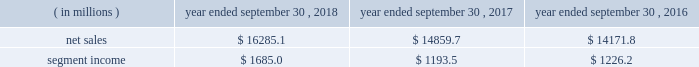Holders of grupo gondi manage the joint venture and we provide technical and commercial resources .
We believe the joint venture is helping us to grow our presence in the attractive mexican market .
We have included the financial results of the joint venture in our corrugated packaging segment since the date of formation .
We are accounting for the investment on the equity method .
On january 19 , 2016 , we completed the packaging acquisition .
The entities acquired provide value-added folding carton and litho-laminated display packaging solutions .
We believe the transaction has provided us with attractive and complementary customers , markets and facilities .
We have included the financial results of the acquired entities in our consumer packaging segment since the date of the acquisition .
On october 1 , 2015 , we completed the sp fiber acquisition .
The transaction included the acquisition of mills located in dublin , ga and newberg , or , which produce lightweight recycled containerboard and kraft and bag paper .
The newberg mill also produced newsprint .
As part of the transaction , we also acquired sp fiber's 48% ( 48 % ) interest in green power solutions of georgia , llc ( fffdgps fffd ) , which we consolidate .
Gps is a joint venture providing steam to the dublin mill and electricity to georgia power .
Subsequent to the transaction , we announced the permanent closure of the newberg mill due to the decline in market conditions of the newsprint business and our need to balance supply and demand in our containerboard system .
We have included the financial results of the acquired entities in our corrugated packaging segment since the date of the acquisition .
See fffdnote 2 .
Mergers , acquisitions and investment fffdtt of the notes to consolidated financial statements for additional information .
See also item 1a .
Fffdrisk factors fffd fffdwe may be unsuccessful in making and integrating mergers , acquisitions and investments and completing divestitures fffd .
Business .
In fiscal 2018 , we continued to pursue our strategy of offering differentiated paper and packaging solutions that help our customers win .
We successfully executed this strategy in fiscal 2018 in a rapidly changing cost and price environment .
Net sales of $ 16285.1 million for fiscal 2018 increased $ 1425.4 million , or 9.6% ( 9.6 % ) , compared to fiscal 2017 .
The increase was primarily a result of an increase in corrugated packaging segment sales , driven by higher selling price/mix and the contributions from acquisitions , and increased consumer packaging segment sales , primarily due to the contribution from acquisitions ( primarily the mps acquisition ) .
These increases were partially offset by the absence of net sales from hh&b in fiscal 2018 due to the sale of hh&b in april 2017 and lower land and development segment sales compared to the prior year period due to the timing of real estate sales as we monetize the portfolio and lower merchandising display sales in the consumer packaging segment .
Segment income increased $ 491.5 million in fiscal 2018 compared to fiscal 2017 , primarily due to increased corrugated packaging segment income .
With respect to segment income , we experienced higher levels of cost inflation during fiscal 2018 as compared to fiscal 2017 , which was partially offset by recycled fiber deflation .
The primary inflationary items were freight costs , chemical costs , virgin fiber costs and wage and other costs .
Productivity improvements in fiscal 2018 more than offset the net impact of cost inflation .
While it is difficult to predict specific inflationary items , we expect higher cost inflation to continue through fiscal 2019 .
Our corrugated packaging segment increased its net sales by $ 695.1 million in fiscal 2018 to $ 9103.4 million from $ 8408.3 million in fiscal 2017 .
The increase in net sales was primarily due to higher corrugated selling price/mix and higher corrugated volumes ( including acquisitions ) , which were partially offset by lower net sales from recycling operations due to lower recycled fiber costs , lower sales related to the deconsolidation of a foreign joint venture in fiscal 2017 and the impact of foreign currency .
North american box shipments increased 4.1% ( 4.1 % ) on a per day basis in fiscal 2018 compared to fiscal 2017 .
Segment income attributable to the corrugated packaging segment in fiscal 2018 increased $ 454.0 million to $ 1207.9 million compared to $ 753.9 million in fiscal 2017 .
The increase was primarily due to higher selling price/mix , lower recycled fiber costs and productivity improvements which were partially offset by higher levels of cost inflation and other items , including increased depreciation and amortization .
Our consumer packaging segment increased its net sales by $ 838.9 million in fiscal 2018 to $ 7291.4 million from $ 6452.5 million in fiscal 2017 .
The increase in net sales was primarily due to an increase in net sales from acquisitions ( primarily the mps acquisition ) and higher selling price/mix partially offset by the absence of net sales from hh&b in fiscal 2018 due to the hh&b sale in april 2017 and lower volumes .
Segment income attributable to .
What percentage of net sales was the consumer packaging segment in 2018? 
Rationale: in line 36 , it gives us the amount of of net sales produced by the consumer packaging segment . to find the answer you take net sales subtract that by the number given in line 36 . then divide the solution by net sales .
Computations: ((16285.1 - 7291.4) / 16285.1)
Answer: 0.55227. Holders of grupo gondi manage the joint venture and we provide technical and commercial resources .
We believe the joint venture is helping us to grow our presence in the attractive mexican market .
We have included the financial results of the joint venture in our corrugated packaging segment since the date of formation .
We are accounting for the investment on the equity method .
On january 19 , 2016 , we completed the packaging acquisition .
The entities acquired provide value-added folding carton and litho-laminated display packaging solutions .
We believe the transaction has provided us with attractive and complementary customers , markets and facilities .
We have included the financial results of the acquired entities in our consumer packaging segment since the date of the acquisition .
On october 1 , 2015 , we completed the sp fiber acquisition .
The transaction included the acquisition of mills located in dublin , ga and newberg , or , which produce lightweight recycled containerboard and kraft and bag paper .
The newberg mill also produced newsprint .
As part of the transaction , we also acquired sp fiber's 48% ( 48 % ) interest in green power solutions of georgia , llc ( fffdgps fffd ) , which we consolidate .
Gps is a joint venture providing steam to the dublin mill and electricity to georgia power .
Subsequent to the transaction , we announced the permanent closure of the newberg mill due to the decline in market conditions of the newsprint business and our need to balance supply and demand in our containerboard system .
We have included the financial results of the acquired entities in our corrugated packaging segment since the date of the acquisition .
See fffdnote 2 .
Mergers , acquisitions and investment fffdtt of the notes to consolidated financial statements for additional information .
See also item 1a .
Fffdrisk factors fffd fffdwe may be unsuccessful in making and integrating mergers , acquisitions and investments and completing divestitures fffd .
Business .
In fiscal 2018 , we continued to pursue our strategy of offering differentiated paper and packaging solutions that help our customers win .
We successfully executed this strategy in fiscal 2018 in a rapidly changing cost and price environment .
Net sales of $ 16285.1 million for fiscal 2018 increased $ 1425.4 million , or 9.6% ( 9.6 % ) , compared to fiscal 2017 .
The increase was primarily a result of an increase in corrugated packaging segment sales , driven by higher selling price/mix and the contributions from acquisitions , and increased consumer packaging segment sales , primarily due to the contribution from acquisitions ( primarily the mps acquisition ) .
These increases were partially offset by the absence of net sales from hh&b in fiscal 2018 due to the sale of hh&b in april 2017 and lower land and development segment sales compared to the prior year period due to the timing of real estate sales as we monetize the portfolio and lower merchandising display sales in the consumer packaging segment .
Segment income increased $ 491.5 million in fiscal 2018 compared to fiscal 2017 , primarily due to increased corrugated packaging segment income .
With respect to segment income , we experienced higher levels of cost inflation during fiscal 2018 as compared to fiscal 2017 , which was partially offset by recycled fiber deflation .
The primary inflationary items were freight costs , chemical costs , virgin fiber costs and wage and other costs .
Productivity improvements in fiscal 2018 more than offset the net impact of cost inflation .
While it is difficult to predict specific inflationary items , we expect higher cost inflation to continue through fiscal 2019 .
Our corrugated packaging segment increased its net sales by $ 695.1 million in fiscal 2018 to $ 9103.4 million from $ 8408.3 million in fiscal 2017 .
The increase in net sales was primarily due to higher corrugated selling price/mix and higher corrugated volumes ( including acquisitions ) , which were partially offset by lower net sales from recycling operations due to lower recycled fiber costs , lower sales related to the deconsolidation of a foreign joint venture in fiscal 2017 and the impact of foreign currency .
North american box shipments increased 4.1% ( 4.1 % ) on a per day basis in fiscal 2018 compared to fiscal 2017 .
Segment income attributable to the corrugated packaging segment in fiscal 2018 increased $ 454.0 million to $ 1207.9 million compared to $ 753.9 million in fiscal 2017 .
The increase was primarily due to higher selling price/mix , lower recycled fiber costs and productivity improvements which were partially offset by higher levels of cost inflation and other items , including increased depreciation and amortization .
Our consumer packaging segment increased its net sales by $ 838.9 million in fiscal 2018 to $ 7291.4 million from $ 6452.5 million in fiscal 2017 .
The increase in net sales was primarily due to an increase in net sales from acquisitions ( primarily the mps acquisition ) and higher selling price/mix partially offset by the absence of net sales from hh&b in fiscal 2018 due to the hh&b sale in april 2017 and lower volumes .
Segment income attributable to .
In 2018 , what percent of net sales did the segment income amount to? 
Computations: (1685.0 / 16285.1)
Answer: 0.10347. Holders of grupo gondi manage the joint venture and we provide technical and commercial resources .
We believe the joint venture is helping us to grow our presence in the attractive mexican market .
We have included the financial results of the joint venture in our corrugated packaging segment since the date of formation .
We are accounting for the investment on the equity method .
On january 19 , 2016 , we completed the packaging acquisition .
The entities acquired provide value-added folding carton and litho-laminated display packaging solutions .
We believe the transaction has provided us with attractive and complementary customers , markets and facilities .
We have included the financial results of the acquired entities in our consumer packaging segment since the date of the acquisition .
On october 1 , 2015 , we completed the sp fiber acquisition .
The transaction included the acquisition of mills located in dublin , ga and newberg , or , which produce lightweight recycled containerboard and kraft and bag paper .
The newberg mill also produced newsprint .
As part of the transaction , we also acquired sp fiber's 48% ( 48 % ) interest in green power solutions of georgia , llc ( fffdgps fffd ) , which we consolidate .
Gps is a joint venture providing steam to the dublin mill and electricity to georgia power .
Subsequent to the transaction , we announced the permanent closure of the newberg mill due to the decline in market conditions of the newsprint business and our need to balance supply and demand in our containerboard system .
We have included the financial results of the acquired entities in our corrugated packaging segment since the date of the acquisition .
See fffdnote 2 .
Mergers , acquisitions and investment fffdtt of the notes to consolidated financial statements for additional information .
See also item 1a .
Fffdrisk factors fffd fffdwe may be unsuccessful in making and integrating mergers , acquisitions and investments and completing divestitures fffd .
Business .
In fiscal 2018 , we continued to pursue our strategy of offering differentiated paper and packaging solutions that help our customers win .
We successfully executed this strategy in fiscal 2018 in a rapidly changing cost and price environment .
Net sales of $ 16285.1 million for fiscal 2018 increased $ 1425.4 million , or 9.6% ( 9.6 % ) , compared to fiscal 2017 .
The increase was primarily a result of an increase in corrugated packaging segment sales , driven by higher selling price/mix and the contributions from acquisitions , and increased consumer packaging segment sales , primarily due to the contribution from acquisitions ( primarily the mps acquisition ) .
These increases were partially offset by the absence of net sales from hh&b in fiscal 2018 due to the sale of hh&b in april 2017 and lower land and development segment sales compared to the prior year period due to the timing of real estate sales as we monetize the portfolio and lower merchandising display sales in the consumer packaging segment .
Segment income increased $ 491.5 million in fiscal 2018 compared to fiscal 2017 , primarily due to increased corrugated packaging segment income .
With respect to segment income , we experienced higher levels of cost inflation during fiscal 2018 as compared to fiscal 2017 , which was partially offset by recycled fiber deflation .
The primary inflationary items were freight costs , chemical costs , virgin fiber costs and wage and other costs .
Productivity improvements in fiscal 2018 more than offset the net impact of cost inflation .
While it is difficult to predict specific inflationary items , we expect higher cost inflation to continue through fiscal 2019 .
Our corrugated packaging segment increased its net sales by $ 695.1 million in fiscal 2018 to $ 9103.4 million from $ 8408.3 million in fiscal 2017 .
The increase in net sales was primarily due to higher corrugated selling price/mix and higher corrugated volumes ( including acquisitions ) , which were partially offset by lower net sales from recycling operations due to lower recycled fiber costs , lower sales related to the deconsolidation of a foreign joint venture in fiscal 2017 and the impact of foreign currency .
North american box shipments increased 4.1% ( 4.1 % ) on a per day basis in fiscal 2018 compared to fiscal 2017 .
Segment income attributable to the corrugated packaging segment in fiscal 2018 increased $ 454.0 million to $ 1207.9 million compared to $ 753.9 million in fiscal 2017 .
The increase was primarily due to higher selling price/mix , lower recycled fiber costs and productivity improvements which were partially offset by higher levels of cost inflation and other items , including increased depreciation and amortization .
Our consumer packaging segment increased its net sales by $ 838.9 million in fiscal 2018 to $ 7291.4 million from $ 6452.5 million in fiscal 2017 .
The increase in net sales was primarily due to an increase in net sales from acquisitions ( primarily the mps acquisition ) and higher selling price/mix partially offset by the absence of net sales from hh&b in fiscal 2018 due to the hh&b sale in april 2017 and lower volumes .
Segment income attributable to .
What percent did segment income increase from 2017 to 2018? 
Computations: ((1685.0 / 1193.5) - 1)
Answer: 0.41181. Holders of grupo gondi manage the joint venture and we provide technical and commercial resources .
We believe the joint venture is helping us to grow our presence in the attractive mexican market .
We have included the financial results of the joint venture in our corrugated packaging segment since the date of formation .
We are accounting for the investment on the equity method .
On january 19 , 2016 , we completed the packaging acquisition .
The entities acquired provide value-added folding carton and litho-laminated display packaging solutions .
We believe the transaction has provided us with attractive and complementary customers , markets and facilities .
We have included the financial results of the acquired entities in our consumer packaging segment since the date of the acquisition .
On october 1 , 2015 , we completed the sp fiber acquisition .
The transaction included the acquisition of mills located in dublin , ga and newberg , or , which produce lightweight recycled containerboard and kraft and bag paper .
The newberg mill also produced newsprint .
As part of the transaction , we also acquired sp fiber's 48% ( 48 % ) interest in green power solutions of georgia , llc ( fffdgps fffd ) , which we consolidate .
Gps is a joint venture providing steam to the dublin mill and electricity to georgia power .
Subsequent to the transaction , we announced the permanent closure of the newberg mill due to the decline in market conditions of the newsprint business and our need to balance supply and demand in our containerboard system .
We have included the financial results of the acquired entities in our corrugated packaging segment since the date of the acquisition .
See fffdnote 2 .
Mergers , acquisitions and investment fffdtt of the notes to consolidated financial statements for additional information .
See also item 1a .
Fffdrisk factors fffd fffdwe may be unsuccessful in making and integrating mergers , acquisitions and investments and completing divestitures fffd .
Business .
In fiscal 2018 , we continued to pursue our strategy of offering differentiated paper and packaging solutions that help our customers win .
We successfully executed this strategy in fiscal 2018 in a rapidly changing cost and price environment .
Net sales of $ 16285.1 million for fiscal 2018 increased $ 1425.4 million , or 9.6% ( 9.6 % ) , compared to fiscal 2017 .
The increase was primarily a result of an increase in corrugated packaging segment sales , driven by higher selling price/mix and the contributions from acquisitions , and increased consumer packaging segment sales , primarily due to the contribution from acquisitions ( primarily the mps acquisition ) .
These increases were partially offset by the absence of net sales from hh&b in fiscal 2018 due to the sale of hh&b in april 2017 and lower land and development segment sales compared to the prior year period due to the timing of real estate sales as we monetize the portfolio and lower merchandising display sales in the consumer packaging segment .
Segment income increased $ 491.5 million in fiscal 2018 compared to fiscal 2017 , primarily due to increased corrugated packaging segment income .
With respect to segment income , we experienced higher levels of cost inflation during fiscal 2018 as compared to fiscal 2017 , which was partially offset by recycled fiber deflation .
The primary inflationary items were freight costs , chemical costs , virgin fiber costs and wage and other costs .
Productivity improvements in fiscal 2018 more than offset the net impact of cost inflation .
While it is difficult to predict specific inflationary items , we expect higher cost inflation to continue through fiscal 2019 .
Our corrugated packaging segment increased its net sales by $ 695.1 million in fiscal 2018 to $ 9103.4 million from $ 8408.3 million in fiscal 2017 .
The increase in net sales was primarily due to higher corrugated selling price/mix and higher corrugated volumes ( including acquisitions ) , which were partially offset by lower net sales from recycling operations due to lower recycled fiber costs , lower sales related to the deconsolidation of a foreign joint venture in fiscal 2017 and the impact of foreign currency .
North american box shipments increased 4.1% ( 4.1 % ) on a per day basis in fiscal 2018 compared to fiscal 2017 .
Segment income attributable to the corrugated packaging segment in fiscal 2018 increased $ 454.0 million to $ 1207.9 million compared to $ 753.9 million in fiscal 2017 .
The increase was primarily due to higher selling price/mix , lower recycled fiber costs and productivity improvements which were partially offset by higher levels of cost inflation and other items , including increased depreciation and amortization .
Our consumer packaging segment increased its net sales by $ 838.9 million in fiscal 2018 to $ 7291.4 million from $ 6452.5 million in fiscal 2017 .
The increase in net sales was primarily due to an increase in net sales from acquisitions ( primarily the mps acquisition ) and higher selling price/mix partially offset by the absence of net sales from hh&b in fiscal 2018 due to the hh&b sale in april 2017 and lower volumes .
Segment income attributable to .
How much did net sales grow in a percentage from 2016 to 2018? 
Rationale: to figure out how much net sales grew from 2016 to 2018 one must subtract 2018 sales by 2016 and the divide the answer by 2016 sales .
Computations: ((16285.1 - 14171.8) / 14171.8)
Answer: 0.14912. 